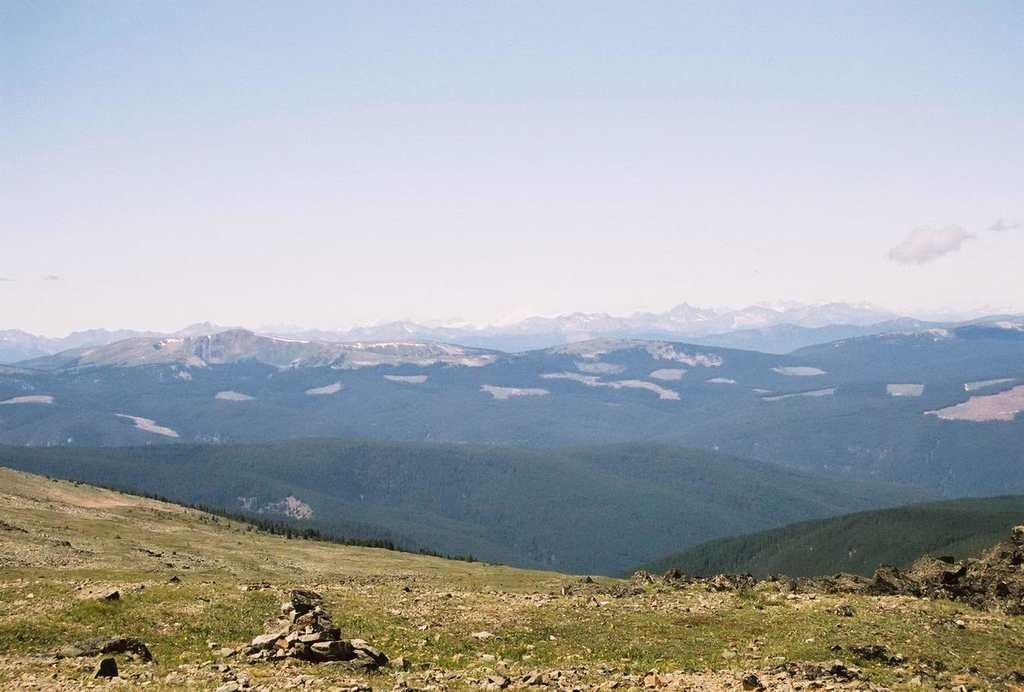Could you give a brief overview of what you see in this image? In the picture we can see a grass surface on the hill and some stones and behind we can see some hills with plants and trees and a rock surface on some hills, and in the background we can see a sky with clouds. 